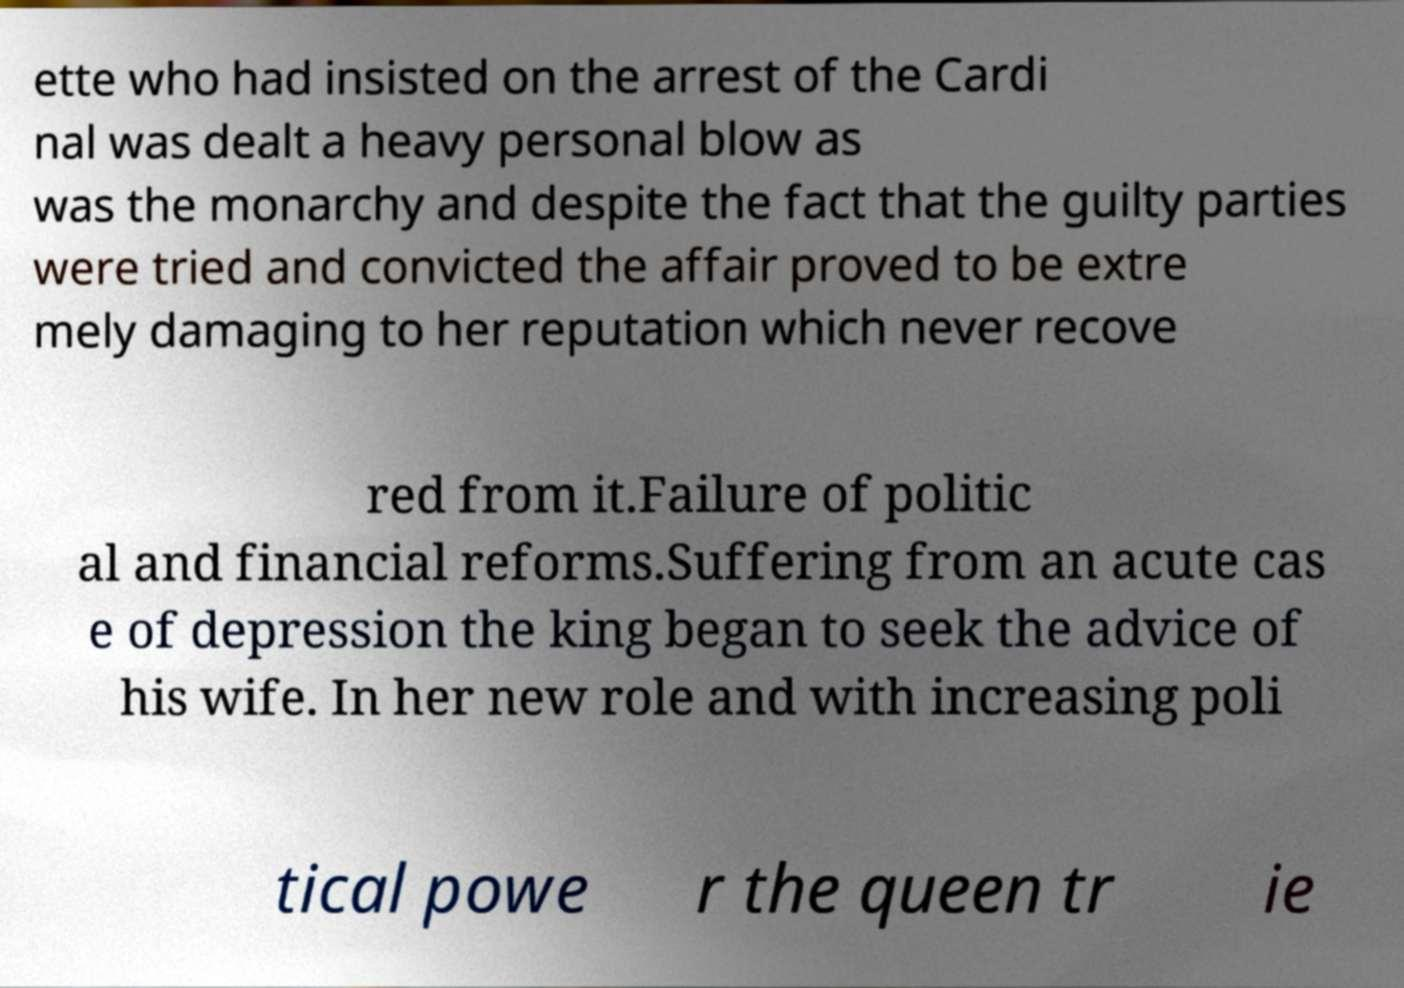There's text embedded in this image that I need extracted. Can you transcribe it verbatim? ette who had insisted on the arrest of the Cardi nal was dealt a heavy personal blow as was the monarchy and despite the fact that the guilty parties were tried and convicted the affair proved to be extre mely damaging to her reputation which never recove red from it.Failure of politic al and financial reforms.Suffering from an acute cas e of depression the king began to seek the advice of his wife. In her new role and with increasing poli tical powe r the queen tr ie 